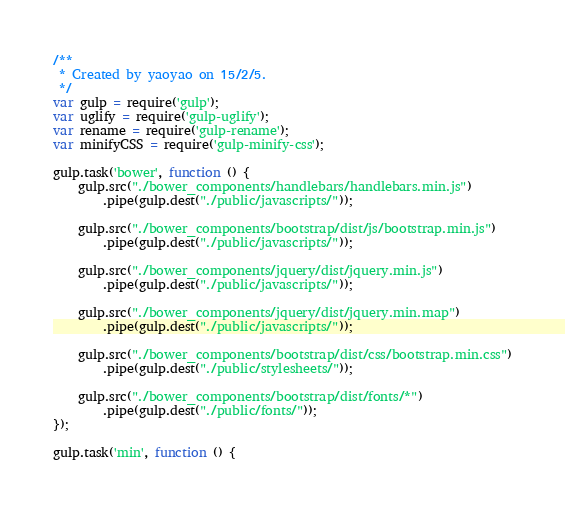<code> <loc_0><loc_0><loc_500><loc_500><_JavaScript_>/**
 * Created by yaoyao on 15/2/5.
 */
var gulp = require('gulp');
var uglify = require('gulp-uglify');
var rename = require('gulp-rename');
var minifyCSS = require('gulp-minify-css');

gulp.task('bower', function () {
    gulp.src("./bower_components/handlebars/handlebars.min.js")
        .pipe(gulp.dest("./public/javascripts/"));

    gulp.src("./bower_components/bootstrap/dist/js/bootstrap.min.js")
        .pipe(gulp.dest("./public/javascripts/"));

    gulp.src("./bower_components/jquery/dist/jquery.min.js")
        .pipe(gulp.dest("./public/javascripts/"));

    gulp.src("./bower_components/jquery/dist/jquery.min.map")
        .pipe(gulp.dest("./public/javascripts/"));

    gulp.src("./bower_components/bootstrap/dist/css/bootstrap.min.css")
        .pipe(gulp.dest("./public/stylesheets/"));

    gulp.src("./bower_components/bootstrap/dist/fonts/*")
        .pipe(gulp.dest("./public/fonts/"));
});

gulp.task('min', function () {</code> 